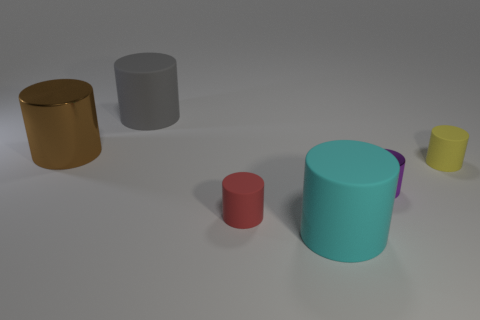Subtract all yellow cylinders. How many cylinders are left? 5 Subtract all tiny red rubber cylinders. How many cylinders are left? 5 Subtract all purple cylinders. Subtract all red blocks. How many cylinders are left? 5 Add 1 red rubber objects. How many objects exist? 7 Subtract all large rubber cylinders. Subtract all big gray matte cylinders. How many objects are left? 3 Add 6 small metal objects. How many small metal objects are left? 7 Add 6 yellow things. How many yellow things exist? 7 Subtract 0 purple balls. How many objects are left? 6 